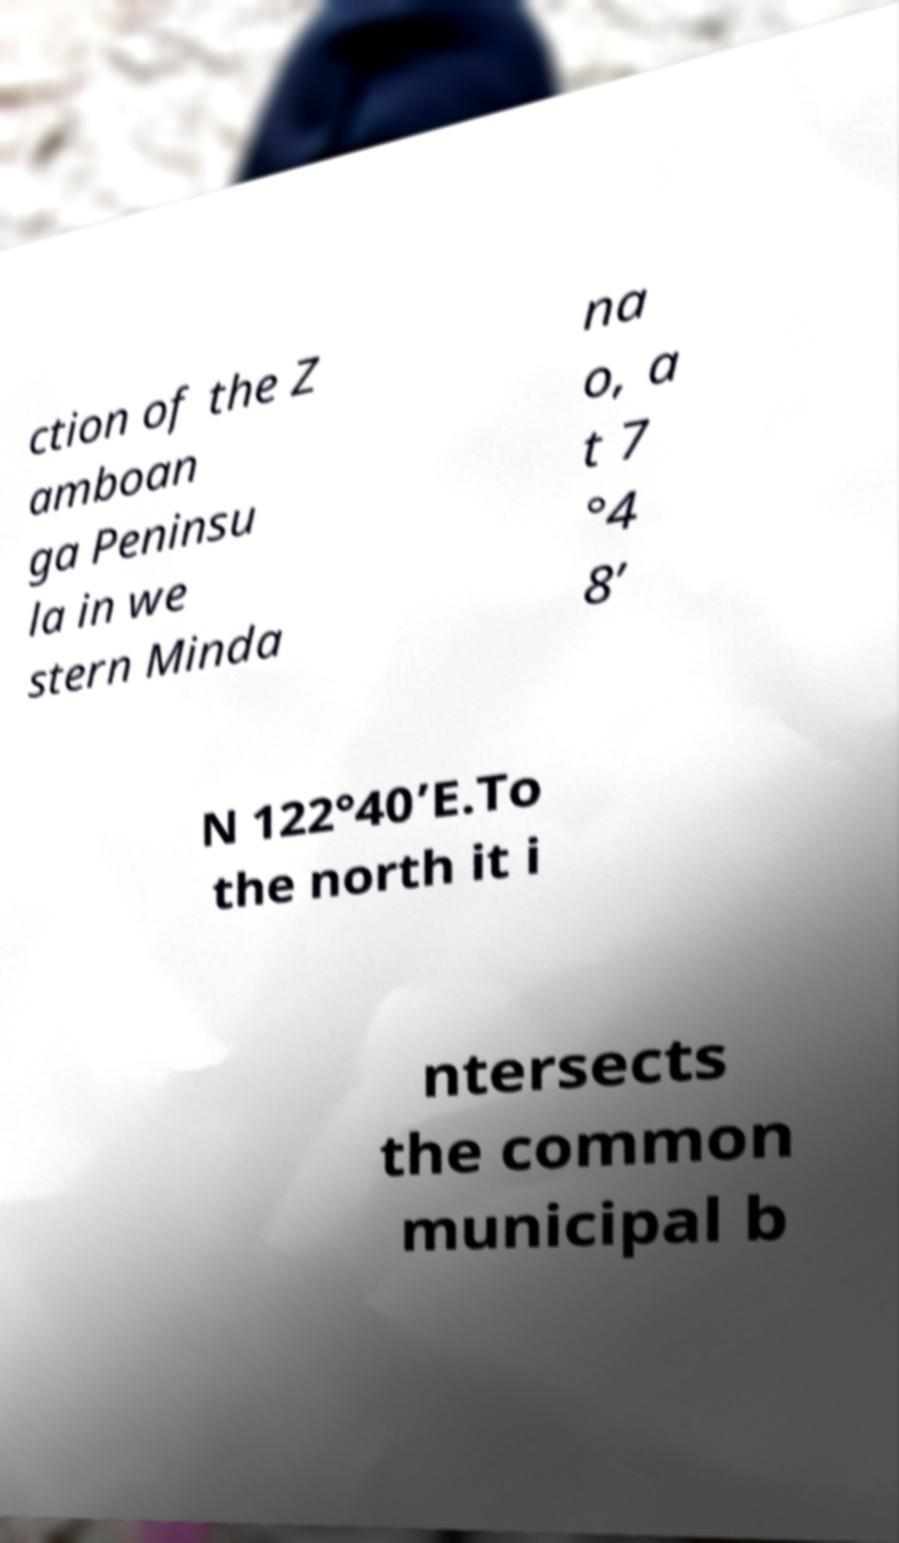I need the written content from this picture converted into text. Can you do that? ction of the Z amboan ga Peninsu la in we stern Minda na o, a t 7 °4 8’ N 122°40’E.To the north it i ntersects the common municipal b 